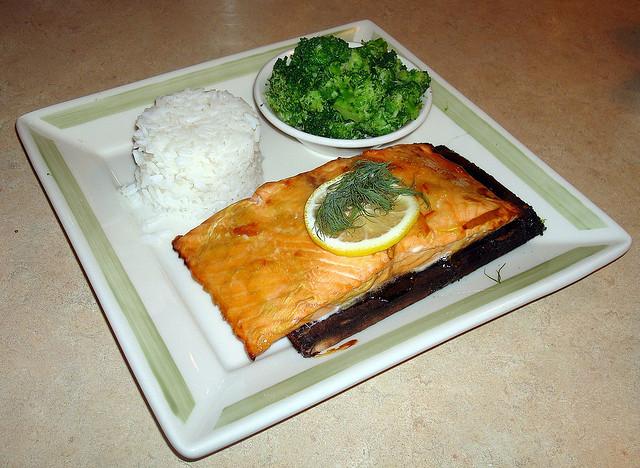Is this a healthy meal?
Concise answer only. Yes. What is the main dish?
Give a very brief answer. Salmon. How many different kinds of food are there?
Short answer required. 3. 